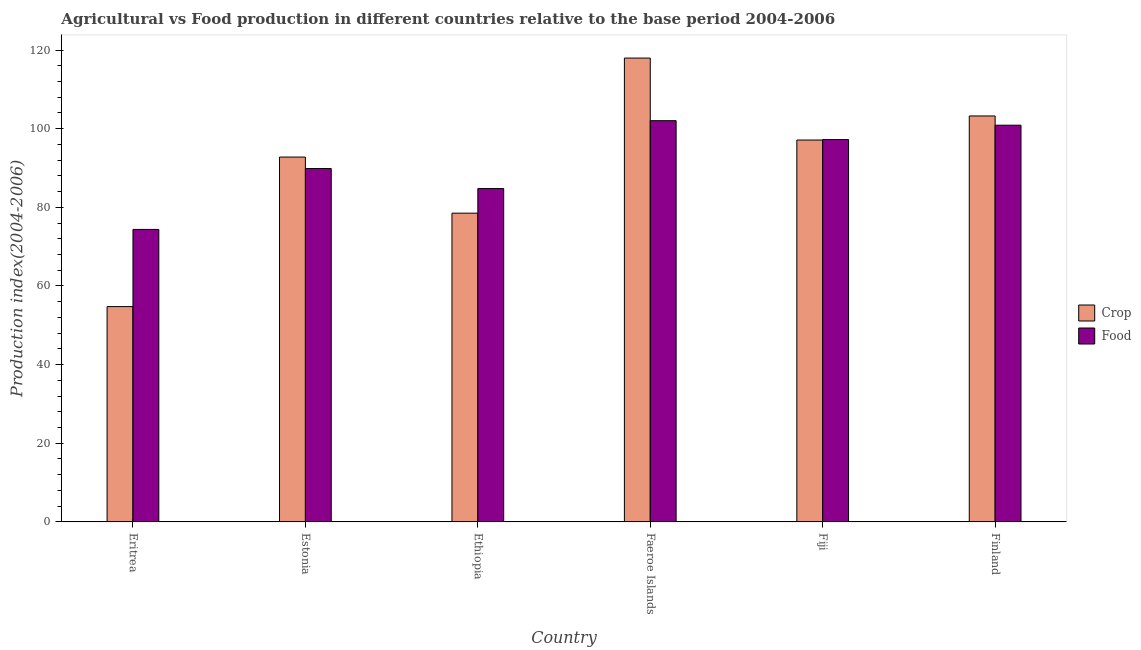How many different coloured bars are there?
Give a very brief answer. 2. How many bars are there on the 1st tick from the left?
Provide a succinct answer. 2. How many bars are there on the 2nd tick from the right?
Your answer should be very brief. 2. What is the label of the 4th group of bars from the left?
Your answer should be compact. Faeroe Islands. In how many cases, is the number of bars for a given country not equal to the number of legend labels?
Give a very brief answer. 0. What is the food production index in Eritrea?
Offer a very short reply. 74.38. Across all countries, what is the maximum food production index?
Make the answer very short. 102.03. Across all countries, what is the minimum food production index?
Offer a very short reply. 74.38. In which country was the food production index maximum?
Your response must be concise. Faeroe Islands. In which country was the food production index minimum?
Provide a succinct answer. Eritrea. What is the total crop production index in the graph?
Provide a short and direct response. 544.33. What is the difference between the food production index in Estonia and that in Finland?
Offer a terse response. -11.02. What is the difference between the food production index in Eritrea and the crop production index in Ethiopia?
Keep it short and to the point. -4.13. What is the average food production index per country?
Your answer should be very brief. 91.52. What is the difference between the food production index and crop production index in Fiji?
Keep it short and to the point. 0.12. In how many countries, is the crop production index greater than 32 ?
Keep it short and to the point. 6. What is the ratio of the food production index in Eritrea to that in Faeroe Islands?
Make the answer very short. 0.73. Is the crop production index in Estonia less than that in Fiji?
Give a very brief answer. Yes. What is the difference between the highest and the second highest food production index?
Your answer should be very brief. 1.15. What is the difference between the highest and the lowest food production index?
Your answer should be compact. 27.65. In how many countries, is the food production index greater than the average food production index taken over all countries?
Your response must be concise. 3. What does the 2nd bar from the left in Finland represents?
Provide a short and direct response. Food. What does the 1st bar from the right in Finland represents?
Your answer should be compact. Food. How many countries are there in the graph?
Your answer should be very brief. 6. What is the difference between two consecutive major ticks on the Y-axis?
Offer a terse response. 20. Does the graph contain any zero values?
Provide a succinct answer. No. Does the graph contain grids?
Ensure brevity in your answer.  No. How many legend labels are there?
Make the answer very short. 2. What is the title of the graph?
Provide a succinct answer. Agricultural vs Food production in different countries relative to the base period 2004-2006. Does "Under-5(female)" appear as one of the legend labels in the graph?
Give a very brief answer. No. What is the label or title of the X-axis?
Offer a very short reply. Country. What is the label or title of the Y-axis?
Provide a short and direct response. Production index(2004-2006). What is the Production index(2004-2006) of Crop in Eritrea?
Provide a short and direct response. 54.75. What is the Production index(2004-2006) in Food in Eritrea?
Provide a succinct answer. 74.38. What is the Production index(2004-2006) of Crop in Estonia?
Provide a short and direct response. 92.78. What is the Production index(2004-2006) in Food in Estonia?
Ensure brevity in your answer.  89.86. What is the Production index(2004-2006) in Crop in Ethiopia?
Give a very brief answer. 78.51. What is the Production index(2004-2006) of Food in Ethiopia?
Make the answer very short. 84.77. What is the Production index(2004-2006) of Crop in Faeroe Islands?
Give a very brief answer. 117.95. What is the Production index(2004-2006) of Food in Faeroe Islands?
Give a very brief answer. 102.03. What is the Production index(2004-2006) in Crop in Fiji?
Keep it short and to the point. 97.11. What is the Production index(2004-2006) of Food in Fiji?
Offer a terse response. 97.23. What is the Production index(2004-2006) of Crop in Finland?
Give a very brief answer. 103.23. What is the Production index(2004-2006) of Food in Finland?
Offer a terse response. 100.88. Across all countries, what is the maximum Production index(2004-2006) of Crop?
Give a very brief answer. 117.95. Across all countries, what is the maximum Production index(2004-2006) of Food?
Your answer should be compact. 102.03. Across all countries, what is the minimum Production index(2004-2006) of Crop?
Your answer should be compact. 54.75. Across all countries, what is the minimum Production index(2004-2006) in Food?
Provide a succinct answer. 74.38. What is the total Production index(2004-2006) in Crop in the graph?
Give a very brief answer. 544.33. What is the total Production index(2004-2006) of Food in the graph?
Offer a terse response. 549.15. What is the difference between the Production index(2004-2006) in Crop in Eritrea and that in Estonia?
Give a very brief answer. -38.03. What is the difference between the Production index(2004-2006) in Food in Eritrea and that in Estonia?
Give a very brief answer. -15.48. What is the difference between the Production index(2004-2006) of Crop in Eritrea and that in Ethiopia?
Offer a terse response. -23.76. What is the difference between the Production index(2004-2006) of Food in Eritrea and that in Ethiopia?
Your response must be concise. -10.39. What is the difference between the Production index(2004-2006) in Crop in Eritrea and that in Faeroe Islands?
Your response must be concise. -63.2. What is the difference between the Production index(2004-2006) in Food in Eritrea and that in Faeroe Islands?
Your response must be concise. -27.65. What is the difference between the Production index(2004-2006) of Crop in Eritrea and that in Fiji?
Keep it short and to the point. -42.36. What is the difference between the Production index(2004-2006) in Food in Eritrea and that in Fiji?
Your answer should be very brief. -22.85. What is the difference between the Production index(2004-2006) in Crop in Eritrea and that in Finland?
Provide a short and direct response. -48.48. What is the difference between the Production index(2004-2006) in Food in Eritrea and that in Finland?
Keep it short and to the point. -26.5. What is the difference between the Production index(2004-2006) in Crop in Estonia and that in Ethiopia?
Ensure brevity in your answer.  14.27. What is the difference between the Production index(2004-2006) in Food in Estonia and that in Ethiopia?
Provide a short and direct response. 5.09. What is the difference between the Production index(2004-2006) of Crop in Estonia and that in Faeroe Islands?
Your answer should be compact. -25.17. What is the difference between the Production index(2004-2006) in Food in Estonia and that in Faeroe Islands?
Offer a terse response. -12.17. What is the difference between the Production index(2004-2006) of Crop in Estonia and that in Fiji?
Your answer should be compact. -4.33. What is the difference between the Production index(2004-2006) of Food in Estonia and that in Fiji?
Offer a very short reply. -7.37. What is the difference between the Production index(2004-2006) in Crop in Estonia and that in Finland?
Provide a succinct answer. -10.45. What is the difference between the Production index(2004-2006) of Food in Estonia and that in Finland?
Offer a very short reply. -11.02. What is the difference between the Production index(2004-2006) in Crop in Ethiopia and that in Faeroe Islands?
Ensure brevity in your answer.  -39.44. What is the difference between the Production index(2004-2006) in Food in Ethiopia and that in Faeroe Islands?
Offer a very short reply. -17.26. What is the difference between the Production index(2004-2006) of Crop in Ethiopia and that in Fiji?
Give a very brief answer. -18.6. What is the difference between the Production index(2004-2006) in Food in Ethiopia and that in Fiji?
Ensure brevity in your answer.  -12.46. What is the difference between the Production index(2004-2006) in Crop in Ethiopia and that in Finland?
Your answer should be very brief. -24.72. What is the difference between the Production index(2004-2006) in Food in Ethiopia and that in Finland?
Provide a succinct answer. -16.11. What is the difference between the Production index(2004-2006) in Crop in Faeroe Islands and that in Fiji?
Keep it short and to the point. 20.84. What is the difference between the Production index(2004-2006) in Crop in Faeroe Islands and that in Finland?
Make the answer very short. 14.72. What is the difference between the Production index(2004-2006) of Food in Faeroe Islands and that in Finland?
Ensure brevity in your answer.  1.15. What is the difference between the Production index(2004-2006) in Crop in Fiji and that in Finland?
Give a very brief answer. -6.12. What is the difference between the Production index(2004-2006) of Food in Fiji and that in Finland?
Offer a terse response. -3.65. What is the difference between the Production index(2004-2006) in Crop in Eritrea and the Production index(2004-2006) in Food in Estonia?
Keep it short and to the point. -35.11. What is the difference between the Production index(2004-2006) in Crop in Eritrea and the Production index(2004-2006) in Food in Ethiopia?
Offer a terse response. -30.02. What is the difference between the Production index(2004-2006) in Crop in Eritrea and the Production index(2004-2006) in Food in Faeroe Islands?
Your response must be concise. -47.28. What is the difference between the Production index(2004-2006) of Crop in Eritrea and the Production index(2004-2006) of Food in Fiji?
Your answer should be compact. -42.48. What is the difference between the Production index(2004-2006) of Crop in Eritrea and the Production index(2004-2006) of Food in Finland?
Provide a succinct answer. -46.13. What is the difference between the Production index(2004-2006) in Crop in Estonia and the Production index(2004-2006) in Food in Ethiopia?
Your answer should be compact. 8.01. What is the difference between the Production index(2004-2006) in Crop in Estonia and the Production index(2004-2006) in Food in Faeroe Islands?
Your answer should be very brief. -9.25. What is the difference between the Production index(2004-2006) of Crop in Estonia and the Production index(2004-2006) of Food in Fiji?
Provide a short and direct response. -4.45. What is the difference between the Production index(2004-2006) in Crop in Ethiopia and the Production index(2004-2006) in Food in Faeroe Islands?
Keep it short and to the point. -23.52. What is the difference between the Production index(2004-2006) in Crop in Ethiopia and the Production index(2004-2006) in Food in Fiji?
Make the answer very short. -18.72. What is the difference between the Production index(2004-2006) of Crop in Ethiopia and the Production index(2004-2006) of Food in Finland?
Give a very brief answer. -22.37. What is the difference between the Production index(2004-2006) of Crop in Faeroe Islands and the Production index(2004-2006) of Food in Fiji?
Provide a succinct answer. 20.72. What is the difference between the Production index(2004-2006) of Crop in Faeroe Islands and the Production index(2004-2006) of Food in Finland?
Your answer should be compact. 17.07. What is the difference between the Production index(2004-2006) of Crop in Fiji and the Production index(2004-2006) of Food in Finland?
Your answer should be very brief. -3.77. What is the average Production index(2004-2006) in Crop per country?
Give a very brief answer. 90.72. What is the average Production index(2004-2006) of Food per country?
Your answer should be very brief. 91.53. What is the difference between the Production index(2004-2006) in Crop and Production index(2004-2006) in Food in Eritrea?
Ensure brevity in your answer.  -19.63. What is the difference between the Production index(2004-2006) in Crop and Production index(2004-2006) in Food in Estonia?
Your response must be concise. 2.92. What is the difference between the Production index(2004-2006) of Crop and Production index(2004-2006) of Food in Ethiopia?
Your answer should be very brief. -6.26. What is the difference between the Production index(2004-2006) of Crop and Production index(2004-2006) of Food in Faeroe Islands?
Your response must be concise. 15.92. What is the difference between the Production index(2004-2006) of Crop and Production index(2004-2006) of Food in Fiji?
Your answer should be compact. -0.12. What is the difference between the Production index(2004-2006) in Crop and Production index(2004-2006) in Food in Finland?
Your answer should be very brief. 2.35. What is the ratio of the Production index(2004-2006) in Crop in Eritrea to that in Estonia?
Offer a very short reply. 0.59. What is the ratio of the Production index(2004-2006) of Food in Eritrea to that in Estonia?
Provide a succinct answer. 0.83. What is the ratio of the Production index(2004-2006) of Crop in Eritrea to that in Ethiopia?
Offer a terse response. 0.7. What is the ratio of the Production index(2004-2006) in Food in Eritrea to that in Ethiopia?
Offer a terse response. 0.88. What is the ratio of the Production index(2004-2006) of Crop in Eritrea to that in Faeroe Islands?
Provide a short and direct response. 0.46. What is the ratio of the Production index(2004-2006) in Food in Eritrea to that in Faeroe Islands?
Keep it short and to the point. 0.73. What is the ratio of the Production index(2004-2006) in Crop in Eritrea to that in Fiji?
Give a very brief answer. 0.56. What is the ratio of the Production index(2004-2006) of Food in Eritrea to that in Fiji?
Make the answer very short. 0.77. What is the ratio of the Production index(2004-2006) of Crop in Eritrea to that in Finland?
Provide a short and direct response. 0.53. What is the ratio of the Production index(2004-2006) in Food in Eritrea to that in Finland?
Make the answer very short. 0.74. What is the ratio of the Production index(2004-2006) in Crop in Estonia to that in Ethiopia?
Provide a succinct answer. 1.18. What is the ratio of the Production index(2004-2006) in Food in Estonia to that in Ethiopia?
Provide a short and direct response. 1.06. What is the ratio of the Production index(2004-2006) in Crop in Estonia to that in Faeroe Islands?
Offer a very short reply. 0.79. What is the ratio of the Production index(2004-2006) of Food in Estonia to that in Faeroe Islands?
Your response must be concise. 0.88. What is the ratio of the Production index(2004-2006) of Crop in Estonia to that in Fiji?
Ensure brevity in your answer.  0.96. What is the ratio of the Production index(2004-2006) of Food in Estonia to that in Fiji?
Your answer should be compact. 0.92. What is the ratio of the Production index(2004-2006) in Crop in Estonia to that in Finland?
Your response must be concise. 0.9. What is the ratio of the Production index(2004-2006) in Food in Estonia to that in Finland?
Your response must be concise. 0.89. What is the ratio of the Production index(2004-2006) of Crop in Ethiopia to that in Faeroe Islands?
Make the answer very short. 0.67. What is the ratio of the Production index(2004-2006) of Food in Ethiopia to that in Faeroe Islands?
Provide a short and direct response. 0.83. What is the ratio of the Production index(2004-2006) in Crop in Ethiopia to that in Fiji?
Make the answer very short. 0.81. What is the ratio of the Production index(2004-2006) in Food in Ethiopia to that in Fiji?
Offer a terse response. 0.87. What is the ratio of the Production index(2004-2006) of Crop in Ethiopia to that in Finland?
Give a very brief answer. 0.76. What is the ratio of the Production index(2004-2006) of Food in Ethiopia to that in Finland?
Provide a succinct answer. 0.84. What is the ratio of the Production index(2004-2006) of Crop in Faeroe Islands to that in Fiji?
Make the answer very short. 1.21. What is the ratio of the Production index(2004-2006) of Food in Faeroe Islands to that in Fiji?
Your answer should be compact. 1.05. What is the ratio of the Production index(2004-2006) in Crop in Faeroe Islands to that in Finland?
Give a very brief answer. 1.14. What is the ratio of the Production index(2004-2006) in Food in Faeroe Islands to that in Finland?
Offer a very short reply. 1.01. What is the ratio of the Production index(2004-2006) in Crop in Fiji to that in Finland?
Offer a very short reply. 0.94. What is the ratio of the Production index(2004-2006) of Food in Fiji to that in Finland?
Provide a succinct answer. 0.96. What is the difference between the highest and the second highest Production index(2004-2006) in Crop?
Ensure brevity in your answer.  14.72. What is the difference between the highest and the second highest Production index(2004-2006) of Food?
Your response must be concise. 1.15. What is the difference between the highest and the lowest Production index(2004-2006) in Crop?
Ensure brevity in your answer.  63.2. What is the difference between the highest and the lowest Production index(2004-2006) of Food?
Provide a succinct answer. 27.65. 